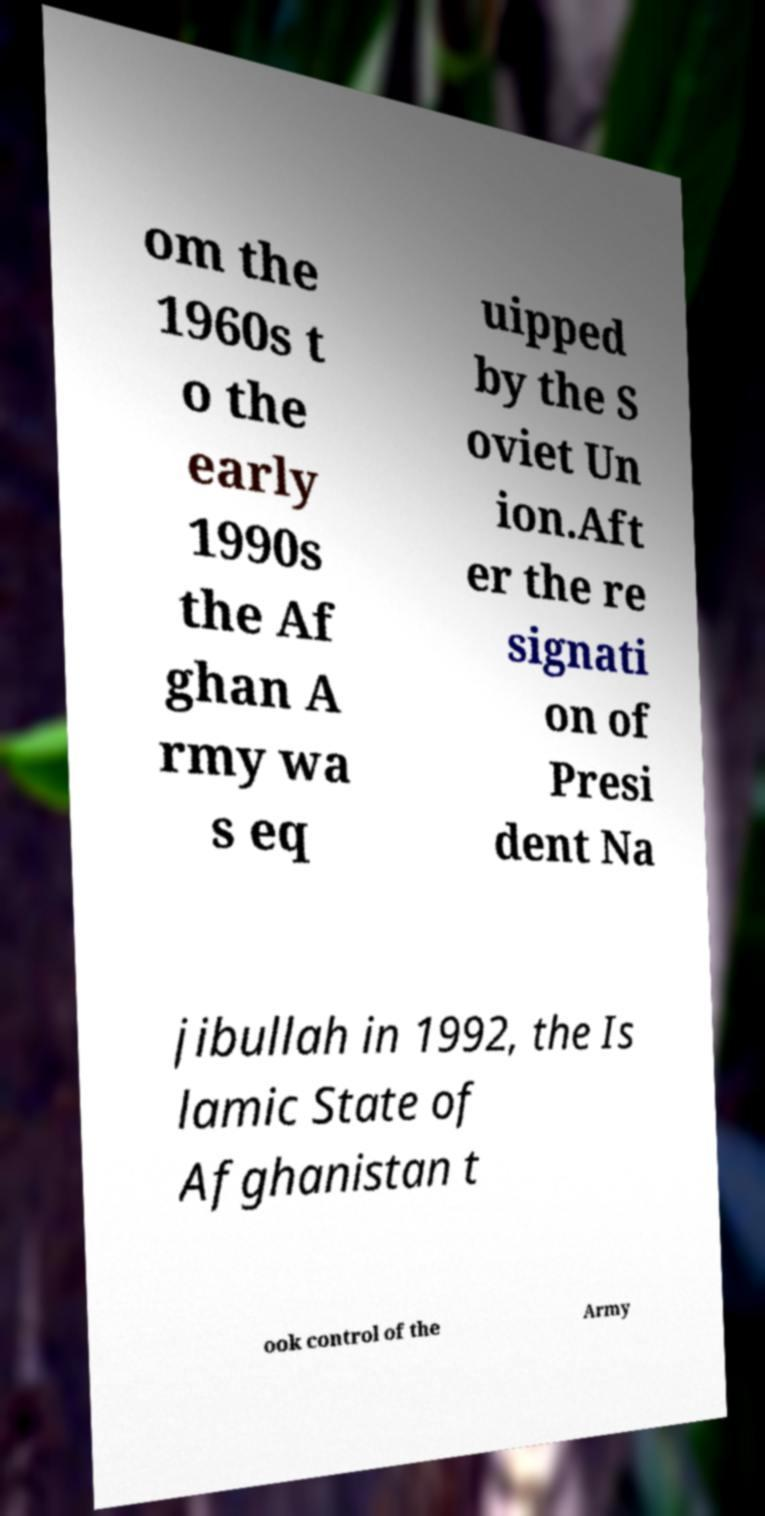Can you read and provide the text displayed in the image?This photo seems to have some interesting text. Can you extract and type it out for me? om the 1960s t o the early 1990s the Af ghan A rmy wa s eq uipped by the S oviet Un ion.Aft er the re signati on of Presi dent Na jibullah in 1992, the Is lamic State of Afghanistan t ook control of the Army 